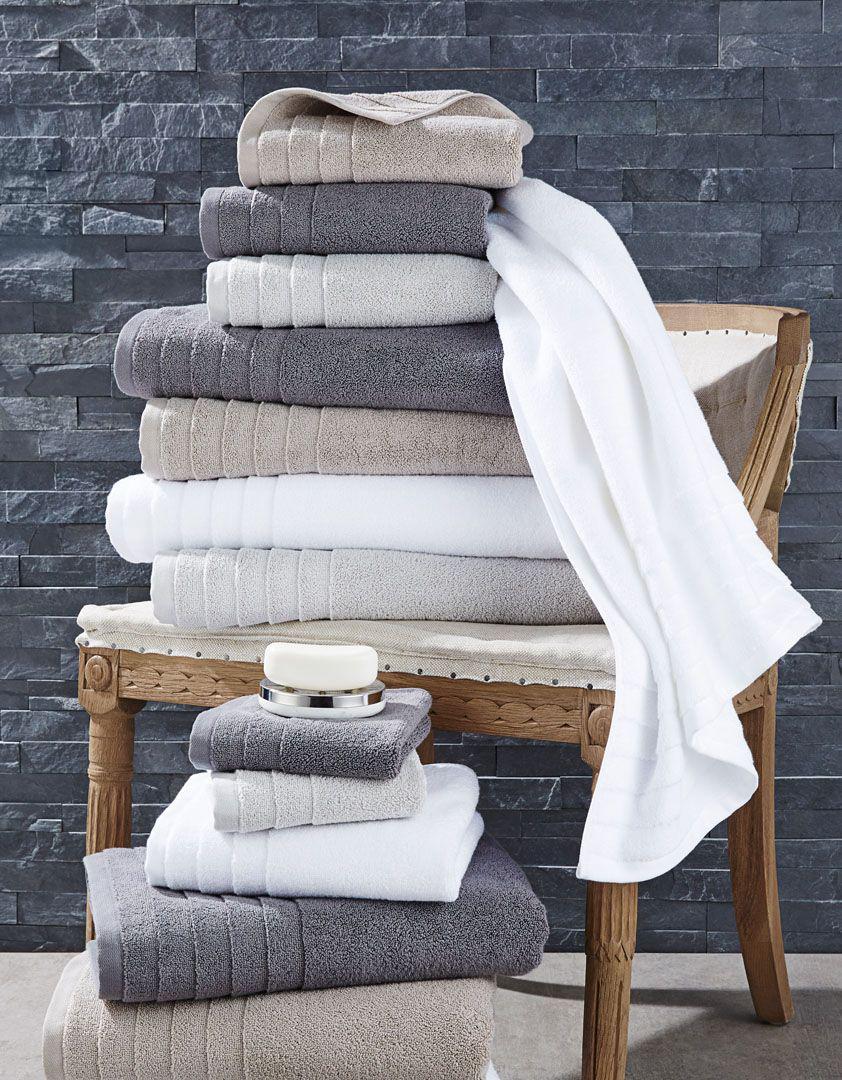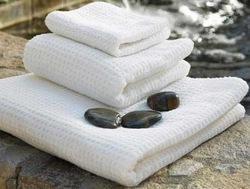The first image is the image on the left, the second image is the image on the right. Assess this claim about the two images: "A toilet is visible in the right image.". Correct or not? Answer yes or no. No. 